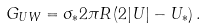<formula> <loc_0><loc_0><loc_500><loc_500>G _ { U W } = \sigma _ { * } 2 \pi R \left ( 2 | U | - U _ { * } \right ) .</formula> 